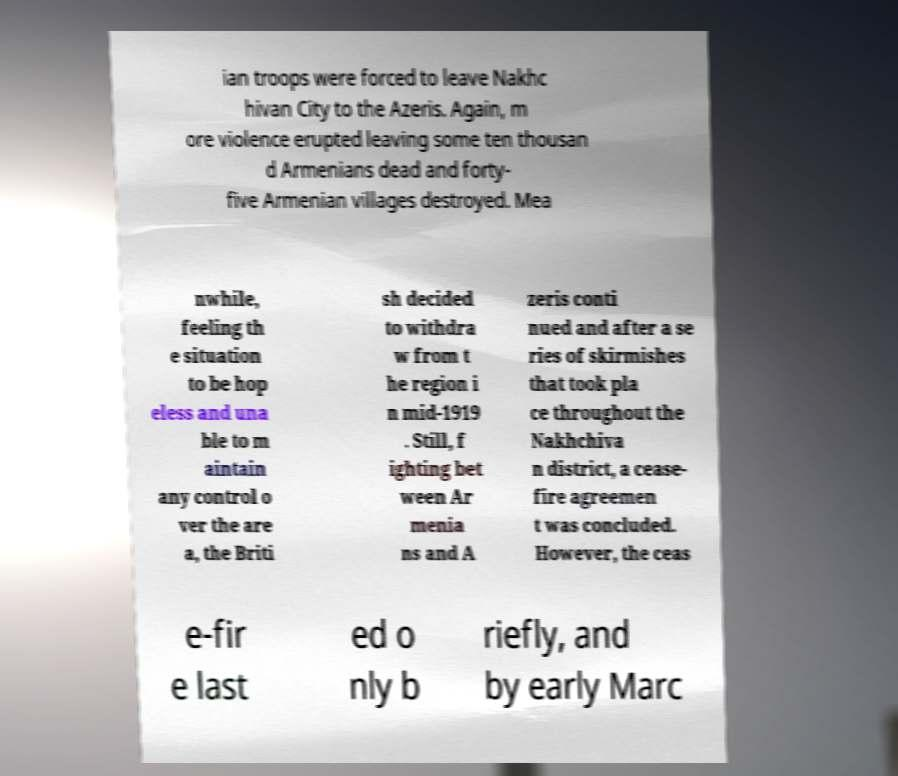For documentation purposes, I need the text within this image transcribed. Could you provide that? ian troops were forced to leave Nakhc hivan City to the Azeris. Again, m ore violence erupted leaving some ten thousan d Armenians dead and forty- five Armenian villages destroyed. Mea nwhile, feeling th e situation to be hop eless and una ble to m aintain any control o ver the are a, the Briti sh decided to withdra w from t he region i n mid-1919 . Still, f ighting bet ween Ar menia ns and A zeris conti nued and after a se ries of skirmishes that took pla ce throughout the Nakhchiva n district, a cease- fire agreemen t was concluded. However, the ceas e-fir e last ed o nly b riefly, and by early Marc 